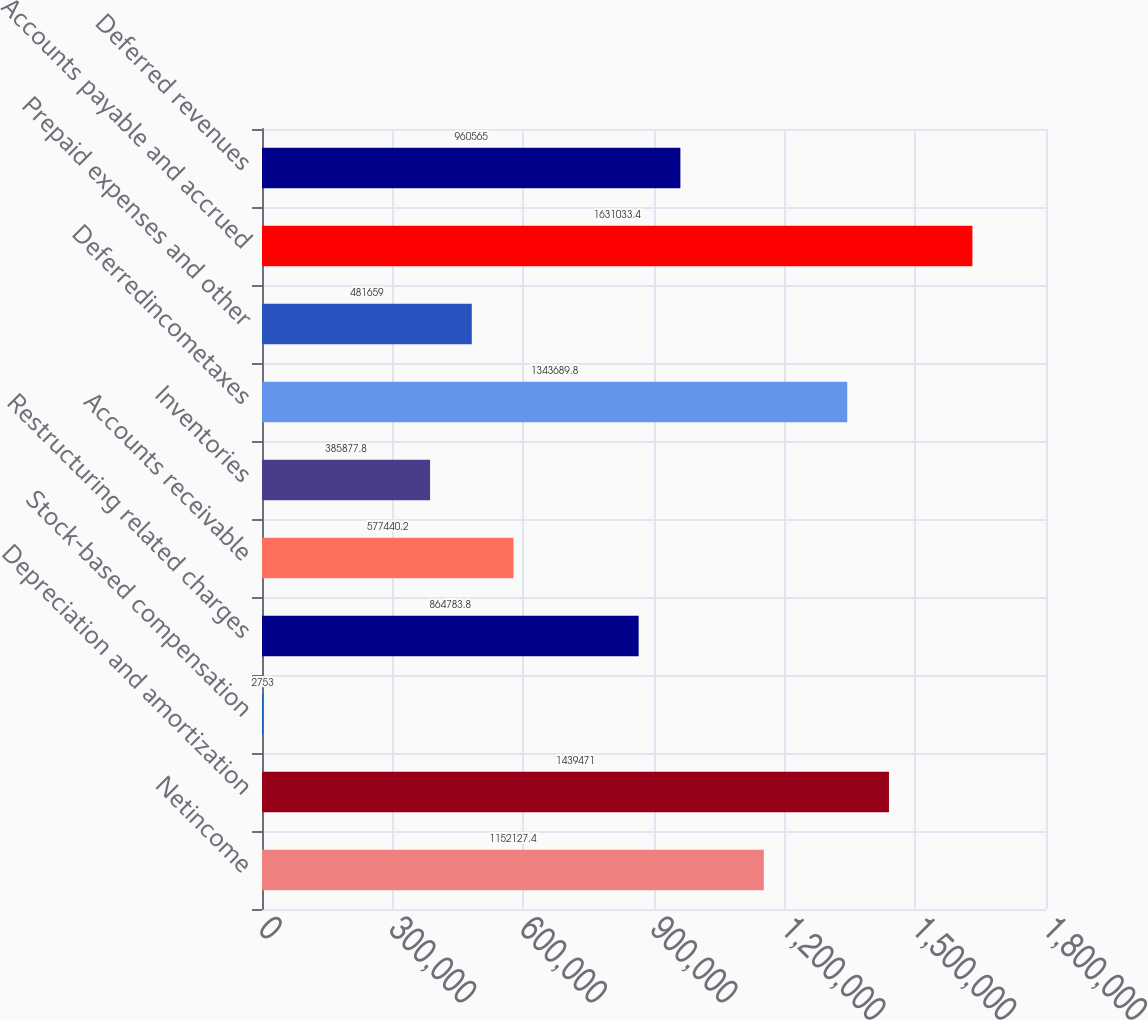<chart> <loc_0><loc_0><loc_500><loc_500><bar_chart><fcel>Netincome<fcel>Depreciation and amortization<fcel>Stock-based compensation<fcel>Restructuring related charges<fcel>Accounts receivable<fcel>Inventories<fcel>Deferredincometaxes<fcel>Prepaid expenses and other<fcel>Accounts payable and accrued<fcel>Deferred revenues<nl><fcel>1.15213e+06<fcel>1.43947e+06<fcel>2753<fcel>864784<fcel>577440<fcel>385878<fcel>1.34369e+06<fcel>481659<fcel>1.63103e+06<fcel>960565<nl></chart> 